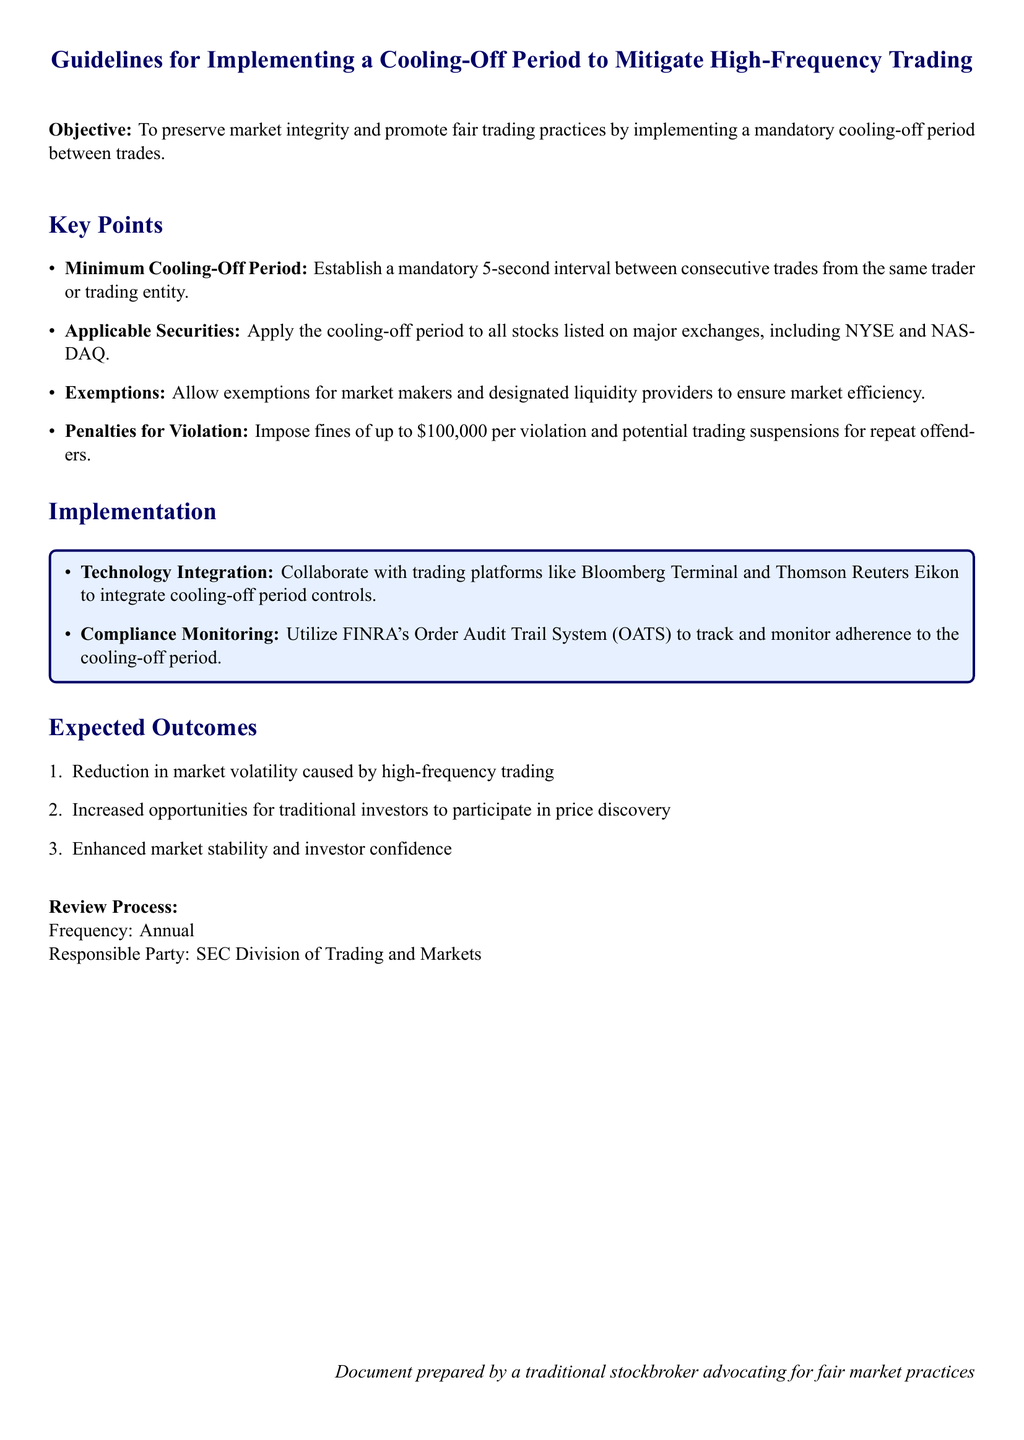What is the objective of the guidelines? The objective is to preserve market integrity and promote fair trading practices by implementing a mandatory cooling-off period between trades.
Answer: To preserve market integrity and promote fair trading practices What is the minimum cooling-off period required? The minimum cooling-off period is specified in the guidelines, indicating the time interval between trades.
Answer: 5 seconds Who is exempt from the cooling-off period? The exemptions allowed in the guidelines are specified to ensure market efficiency.
Answer: Market makers and designated liquidity providers What is the maximum penalty for violating the cooling-off period? The document states the penalty for violations, focusing on the financial aspect of enforcement.
Answer: $100,000 What technology is suggested for integration with the cooling-off period? The guidelines mention specific trading platforms for collaborating on the implementation.
Answer: Bloomberg Terminal and Thomson Reuters Eikon What is the expected outcome related to market volatility? One of the listed outcomes highlights the effect on market stability.
Answer: Reduction in market volatility How often will the review process occur? The document specifies the frequency of monitoring and review to ensure effectiveness.
Answer: Annual Who is responsible for the review process? The responsible party for the review process is noted in the guidelines, indicating oversight authority.
Answer: SEC Division of Trading and Markets 